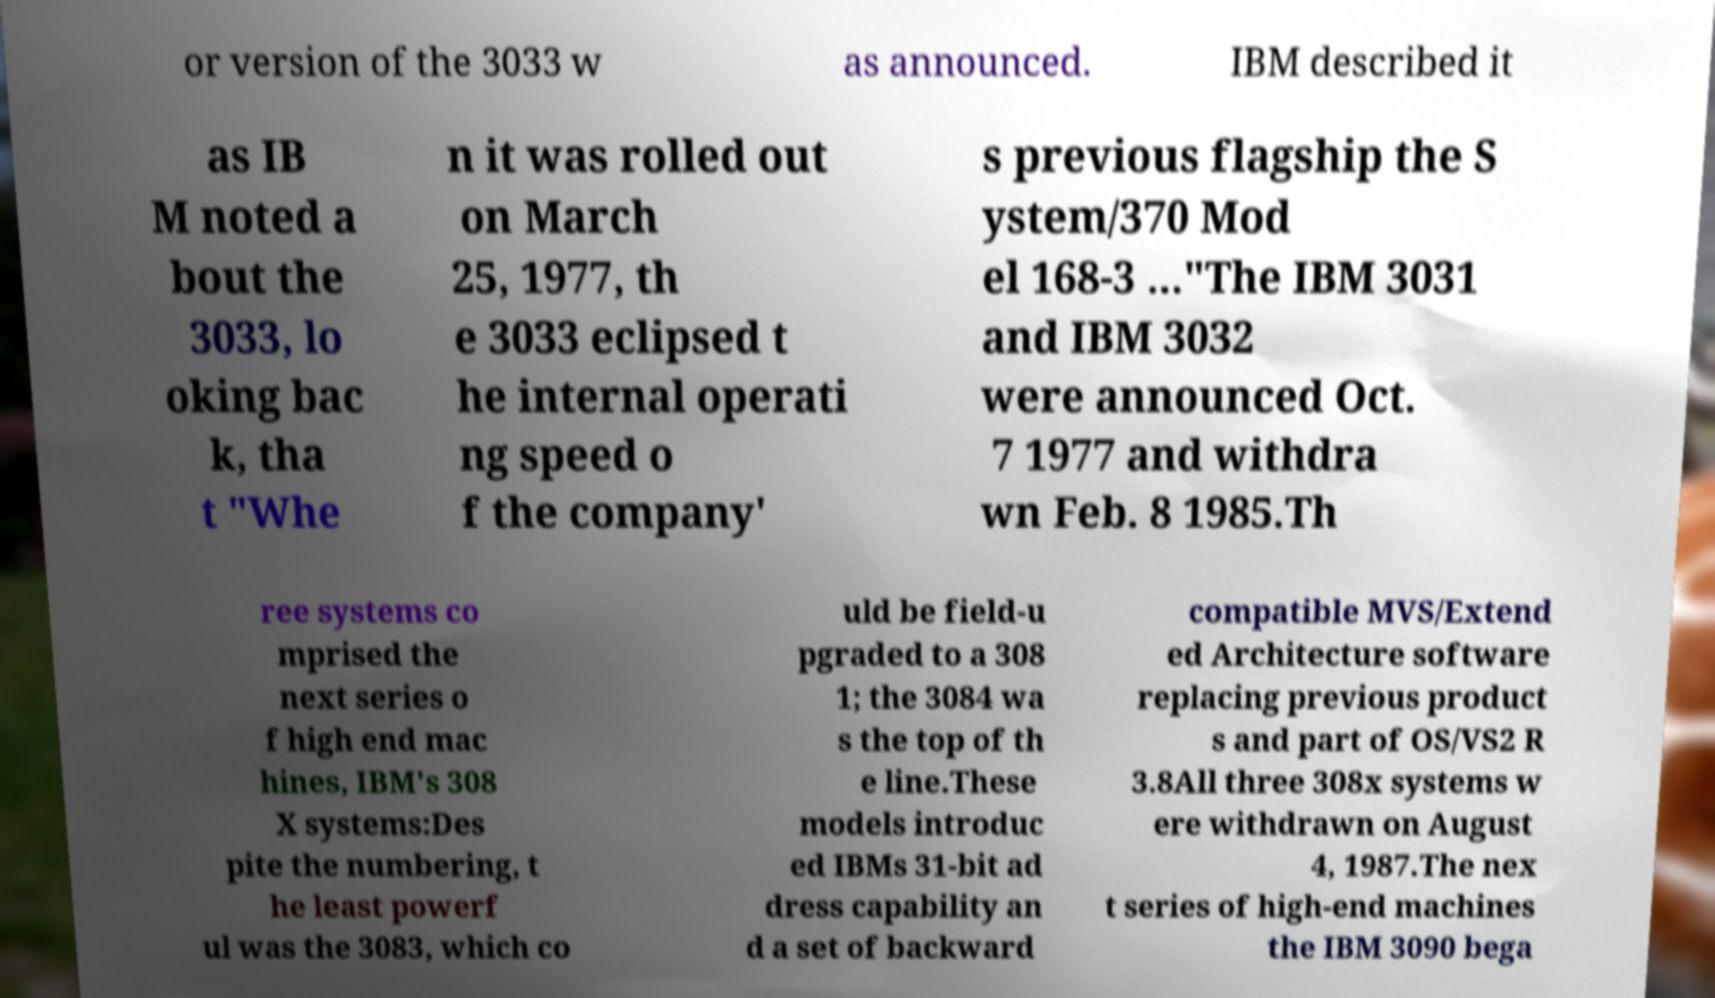I need the written content from this picture converted into text. Can you do that? or version of the 3033 w as announced. IBM described it as IB M noted a bout the 3033, lo oking bac k, tha t "Whe n it was rolled out on March 25, 1977, th e 3033 eclipsed t he internal operati ng speed o f the company' s previous flagship the S ystem/370 Mod el 168-3 ..."The IBM 3031 and IBM 3032 were announced Oct. 7 1977 and withdra wn Feb. 8 1985.Th ree systems co mprised the next series o f high end mac hines, IBM's 308 X systems:Des pite the numbering, t he least powerf ul was the 3083, which co uld be field-u pgraded to a 308 1; the 3084 wa s the top of th e line.These models introduc ed IBMs 31-bit ad dress capability an d a set of backward compatible MVS/Extend ed Architecture software replacing previous product s and part of OS/VS2 R 3.8All three 308x systems w ere withdrawn on August 4, 1987.The nex t series of high-end machines the IBM 3090 bega 